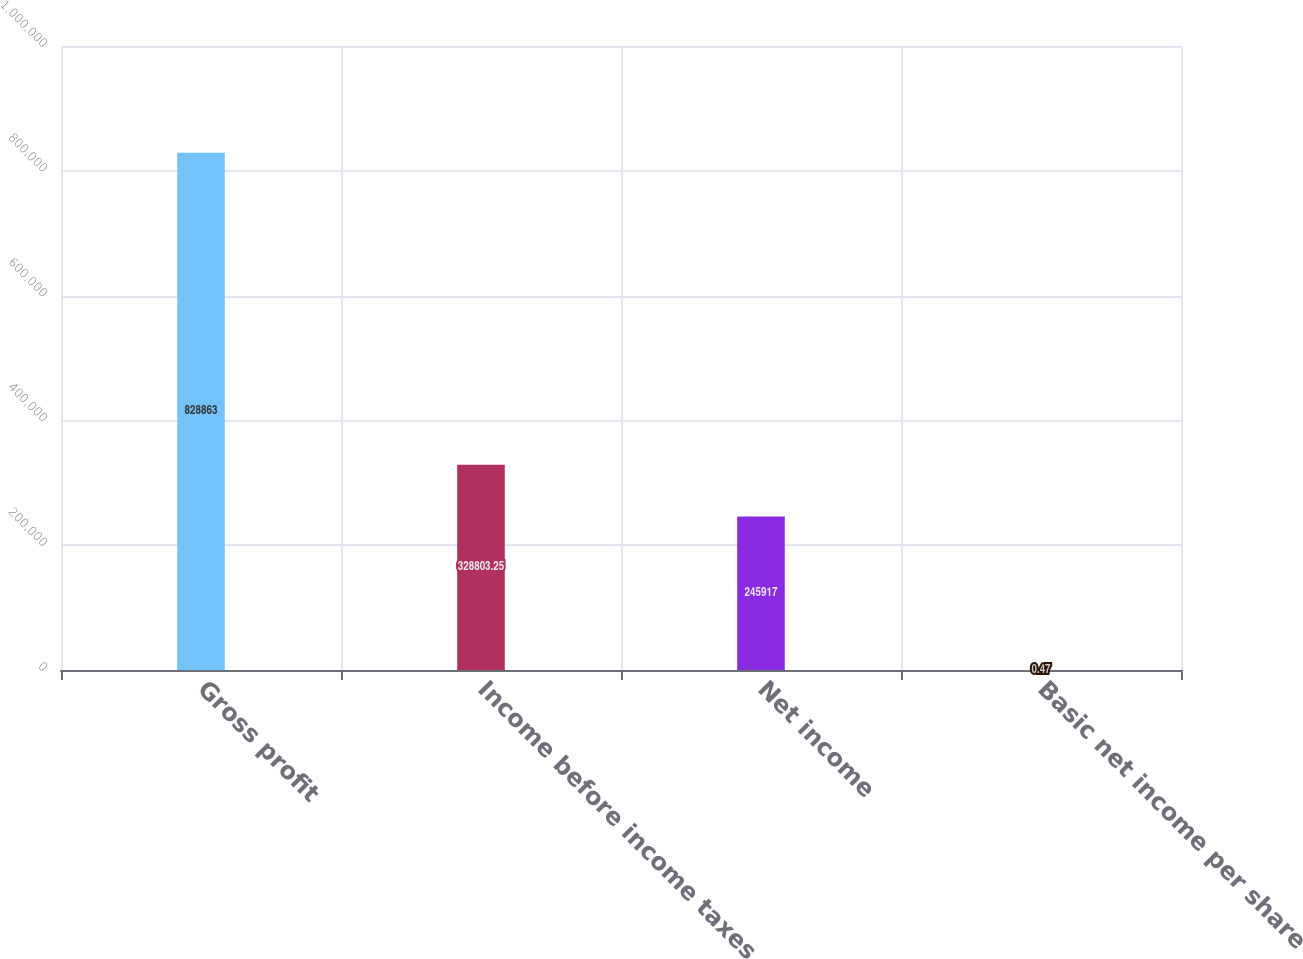Convert chart to OTSL. <chart><loc_0><loc_0><loc_500><loc_500><bar_chart><fcel>Gross profit<fcel>Income before income taxes<fcel>Net income<fcel>Basic net income per share<nl><fcel>828863<fcel>328803<fcel>245917<fcel>0.47<nl></chart> 